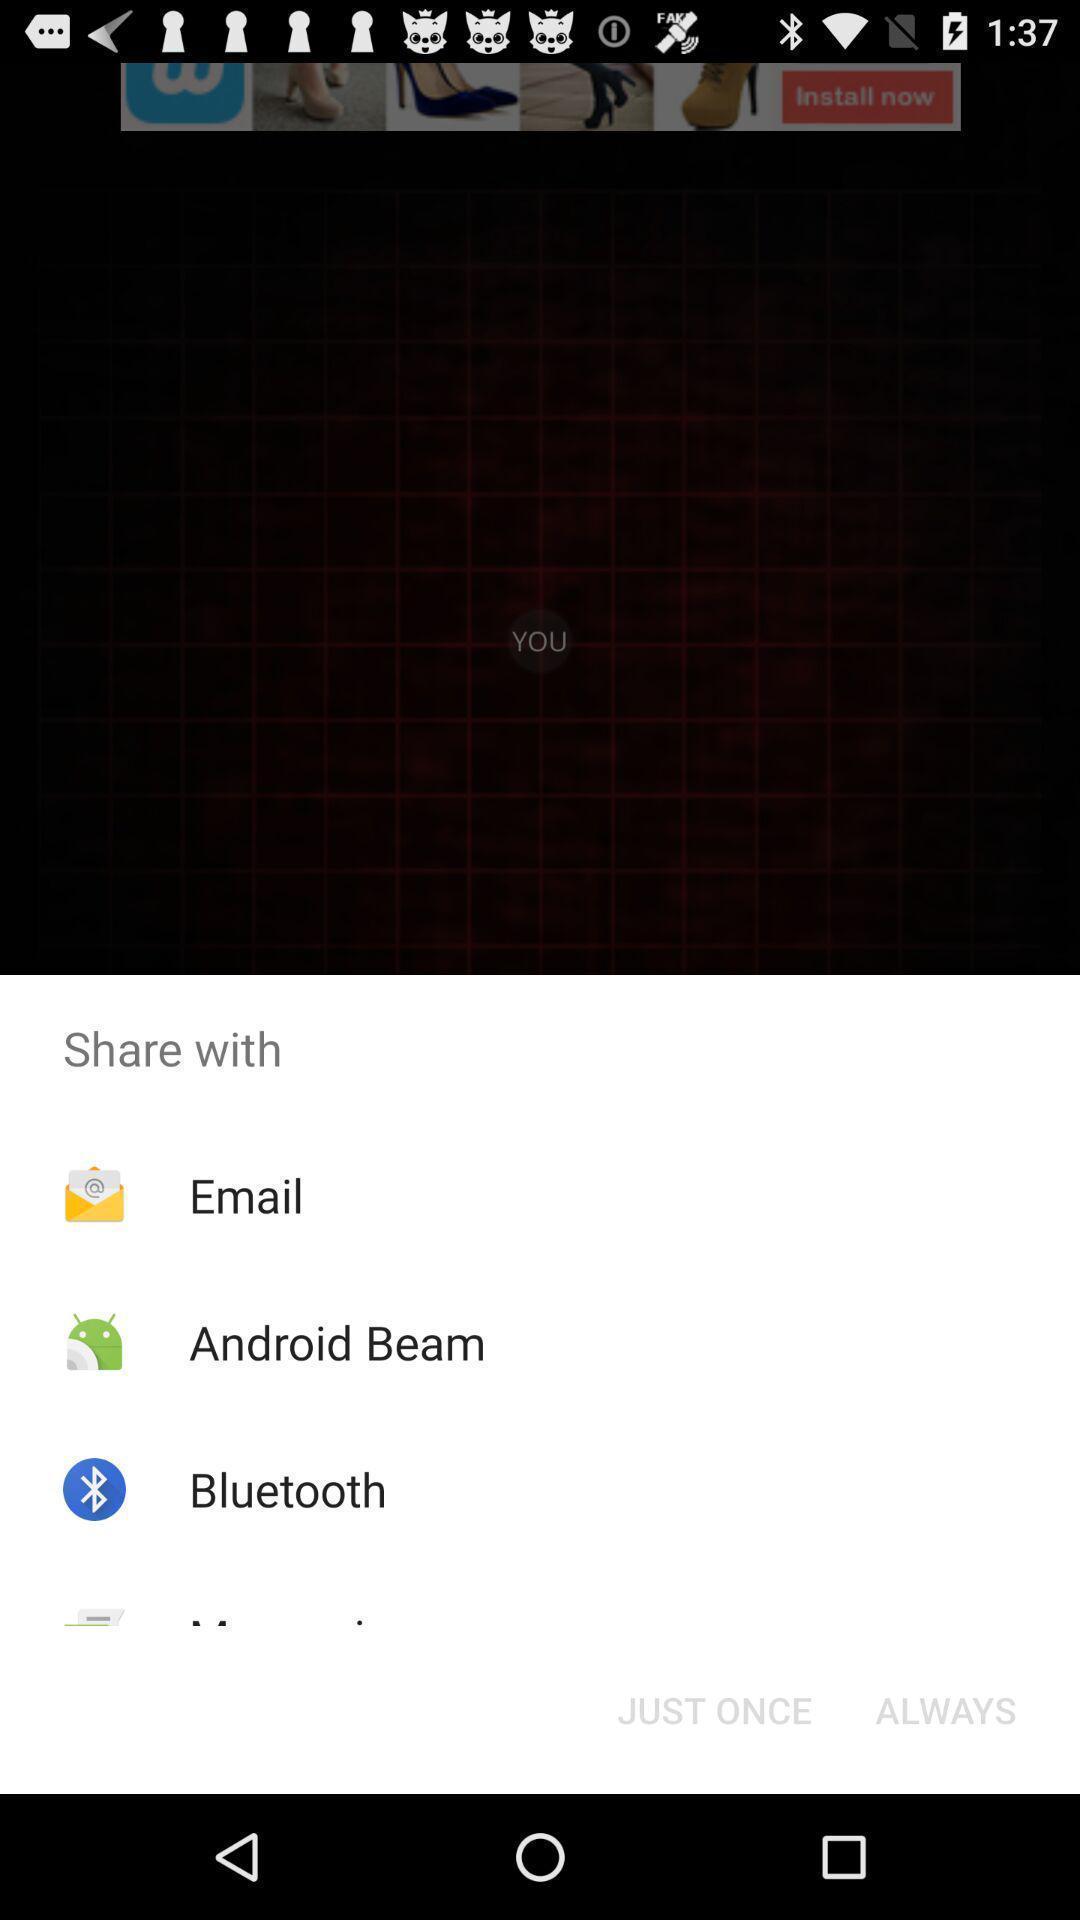Tell me what you see in this picture. Pop-up shows to share with multiple apps. 